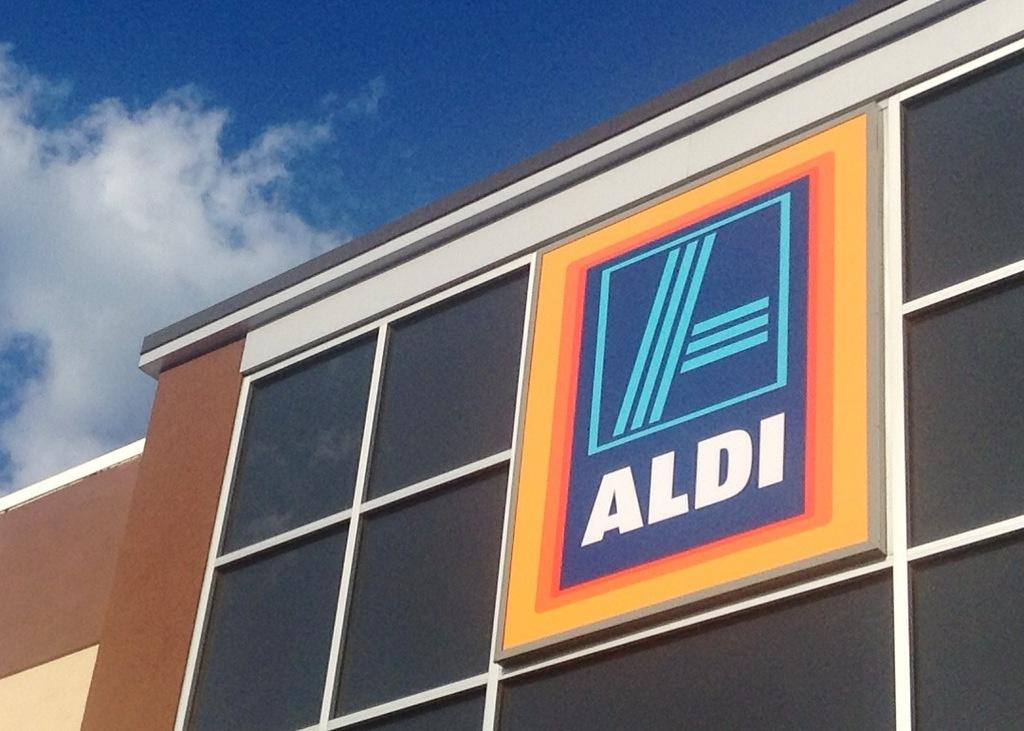What type of structure is visible in the image? There is a building in the image. What is located in front of the building? There is a logo in front of the building. Is there any text associated with the logo? Yes, there is a name under the logo. Can you see any smoke coming from the building in the image? There is no smoke visible in the image. Is there a flock of birds flying near the building in the image? There is no mention of birds or a flock in the provided facts, so we cannot determine if they are present in the image. 